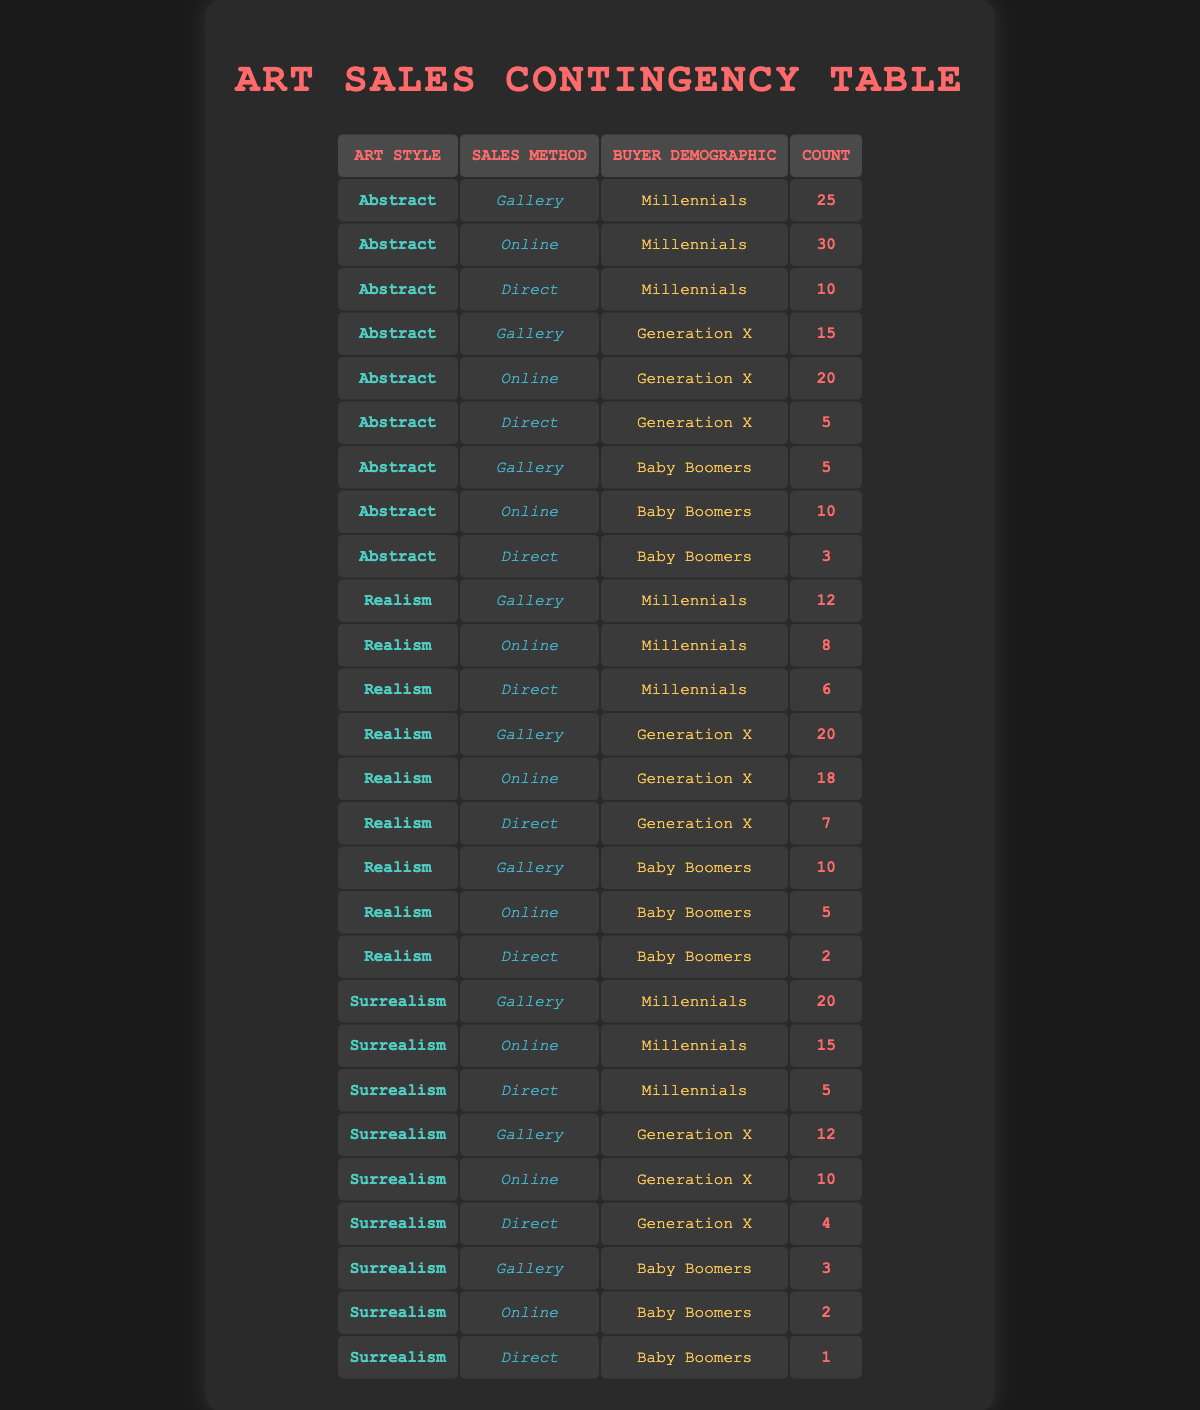What is the total number of Abstract artworks sold to Millennials through online methods? From the table, we can see that 30 Abstract artworks were sold to Millennials through online methods.
Answer: 30 Which Sales Method had the highest count for Generation X in Realism? For Generation X in Realism, the table shows that the Gallery method had the highest count of 20, compared to 18 for Online and 7 for Direct.
Answer: Gallery What is the combined count of Surrealism sold to Millennials through Gallery and Direct methods? For Millennials, Gallery sold 20 and Direct sold 5 in Surrealism, which sums up to 20 + 5 = 25.
Answer: 25 Is there any sales count for Baby Boomers in Surrealism for Online methods? According to the table, Baby Boomers purchased 2 Surrealism artworks through online methods, confirming the count exists.
Answer: Yes How does the count of Realism artworks sold to Millennials through Direct methods compare to those sold to Generation X? The count for Millennials through Direct is 6 while for Generation X it is 7, thus comparing yields a difference of 7 - 6 = 1, meaning Generation X sold 1 more artwork than Millennials.
Answer: Generation X sold 1 more What is the average number of artworks sold across all demographics for the Gallery method in the Abstract style? The counts for Millennials, Generation X, and Baby Boomers for the Gallery method under Abstract are 25, 15, and 5, respectively. The total is 25 + 15 + 5 = 45, and dividing by 3 gives us an average of 45 / 3 = 15.
Answer: 15 